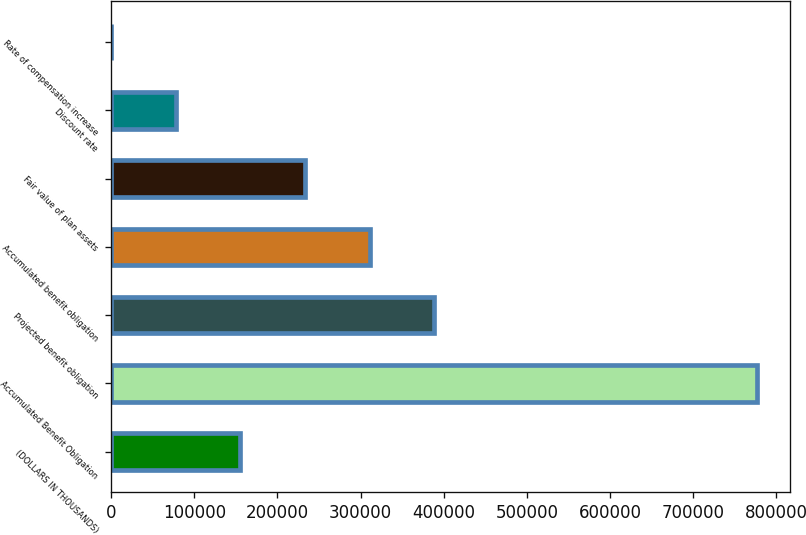Convert chart to OTSL. <chart><loc_0><loc_0><loc_500><loc_500><bar_chart><fcel>(DOLLARS IN THOUSANDS)<fcel>Accumulated Benefit Obligation<fcel>Projected benefit obligation<fcel>Accumulated benefit obligation<fcel>Fair value of plan assets<fcel>Discount rate<fcel>Rate of compensation increase<nl><fcel>155440<fcel>777188<fcel>388595<fcel>310877<fcel>233158<fcel>77721.2<fcel>2.66<nl></chart> 